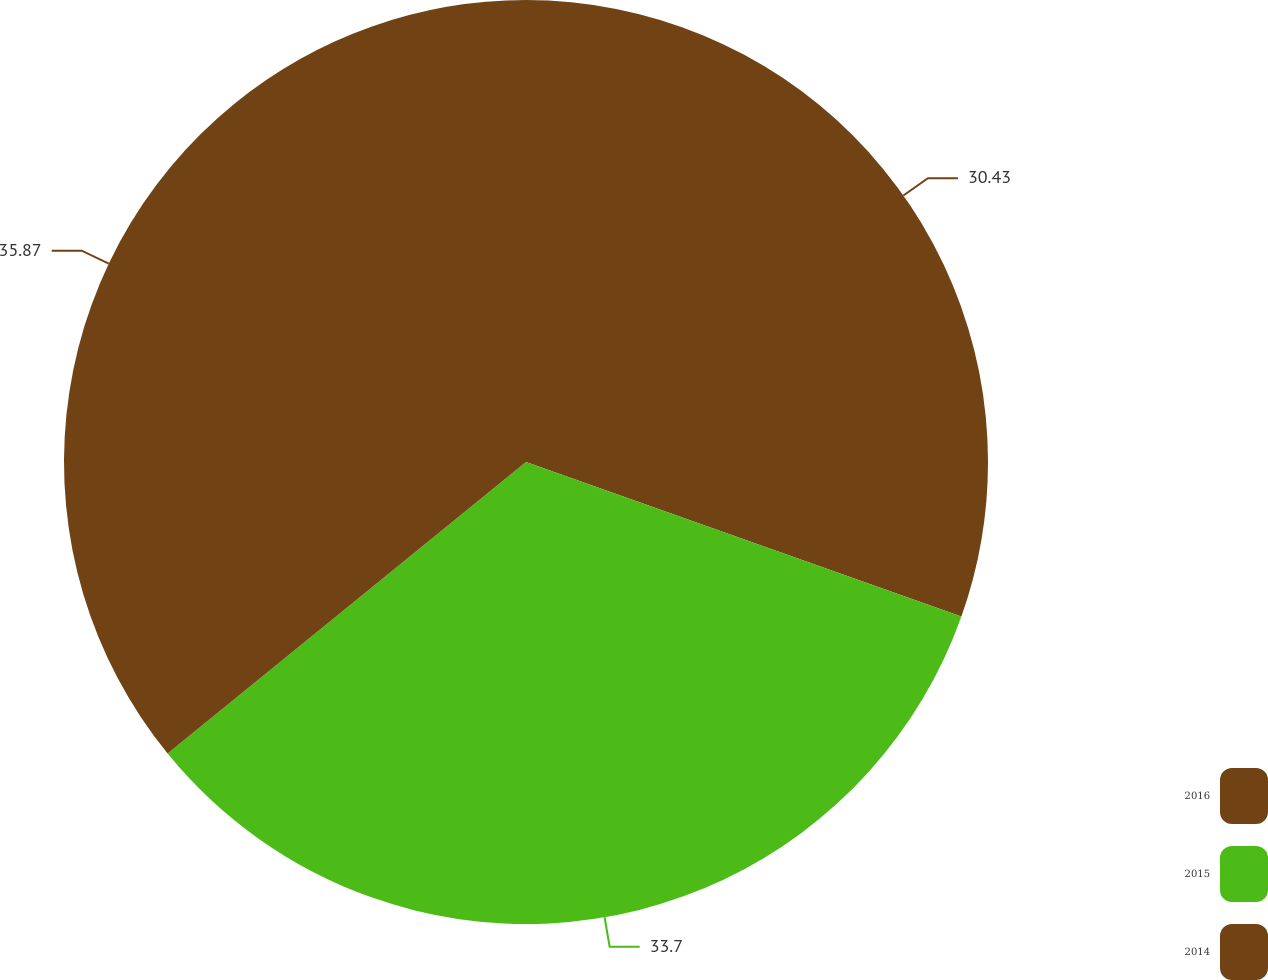Convert chart. <chart><loc_0><loc_0><loc_500><loc_500><pie_chart><fcel>2016<fcel>2015<fcel>2014<nl><fcel>30.43%<fcel>33.7%<fcel>35.87%<nl></chart> 